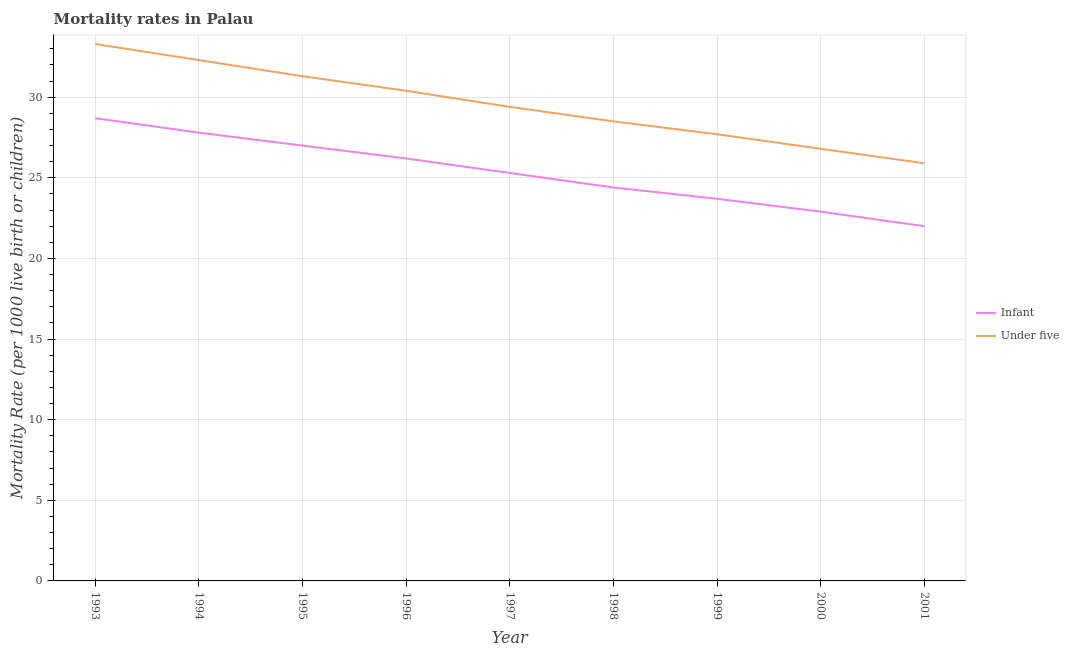What is the under-5 mortality rate in 1995?
Your answer should be compact. 31.3. Across all years, what is the maximum infant mortality rate?
Your response must be concise. 28.7. Across all years, what is the minimum under-5 mortality rate?
Your answer should be very brief. 25.9. In which year was the under-5 mortality rate minimum?
Your answer should be compact. 2001. What is the total under-5 mortality rate in the graph?
Your response must be concise. 265.6. What is the difference between the under-5 mortality rate in 1994 and that in 1995?
Ensure brevity in your answer.  1. What is the difference between the infant mortality rate in 1993 and the under-5 mortality rate in 1994?
Your response must be concise. -3.6. What is the average infant mortality rate per year?
Keep it short and to the point. 25.33. In the year 1997, what is the difference between the infant mortality rate and under-5 mortality rate?
Offer a terse response. -4.1. What is the ratio of the infant mortality rate in 1998 to that in 2000?
Make the answer very short. 1.07. Is the difference between the under-5 mortality rate in 1995 and 2001 greater than the difference between the infant mortality rate in 1995 and 2001?
Offer a terse response. Yes. What is the difference between the highest and the lowest under-5 mortality rate?
Offer a very short reply. 7.4. In how many years, is the under-5 mortality rate greater than the average under-5 mortality rate taken over all years?
Make the answer very short. 4. Is the sum of the infant mortality rate in 1997 and 2000 greater than the maximum under-5 mortality rate across all years?
Make the answer very short. Yes. Does the under-5 mortality rate monotonically increase over the years?
Ensure brevity in your answer.  No. How many years are there in the graph?
Your response must be concise. 9. Are the values on the major ticks of Y-axis written in scientific E-notation?
Your answer should be very brief. No. Does the graph contain any zero values?
Offer a terse response. No. Where does the legend appear in the graph?
Your answer should be compact. Center right. What is the title of the graph?
Ensure brevity in your answer.  Mortality rates in Palau. What is the label or title of the X-axis?
Provide a succinct answer. Year. What is the label or title of the Y-axis?
Provide a succinct answer. Mortality Rate (per 1000 live birth or children). What is the Mortality Rate (per 1000 live birth or children) of Infant in 1993?
Give a very brief answer. 28.7. What is the Mortality Rate (per 1000 live birth or children) in Under five in 1993?
Keep it short and to the point. 33.3. What is the Mortality Rate (per 1000 live birth or children) in Infant in 1994?
Your answer should be very brief. 27.8. What is the Mortality Rate (per 1000 live birth or children) in Under five in 1994?
Your answer should be very brief. 32.3. What is the Mortality Rate (per 1000 live birth or children) of Infant in 1995?
Give a very brief answer. 27. What is the Mortality Rate (per 1000 live birth or children) in Under five in 1995?
Keep it short and to the point. 31.3. What is the Mortality Rate (per 1000 live birth or children) in Infant in 1996?
Offer a very short reply. 26.2. What is the Mortality Rate (per 1000 live birth or children) of Under five in 1996?
Keep it short and to the point. 30.4. What is the Mortality Rate (per 1000 live birth or children) in Infant in 1997?
Provide a short and direct response. 25.3. What is the Mortality Rate (per 1000 live birth or children) of Under five in 1997?
Keep it short and to the point. 29.4. What is the Mortality Rate (per 1000 live birth or children) in Infant in 1998?
Offer a very short reply. 24.4. What is the Mortality Rate (per 1000 live birth or children) of Under five in 1998?
Make the answer very short. 28.5. What is the Mortality Rate (per 1000 live birth or children) of Infant in 1999?
Make the answer very short. 23.7. What is the Mortality Rate (per 1000 live birth or children) of Under five in 1999?
Your answer should be very brief. 27.7. What is the Mortality Rate (per 1000 live birth or children) in Infant in 2000?
Your response must be concise. 22.9. What is the Mortality Rate (per 1000 live birth or children) in Under five in 2000?
Provide a succinct answer. 26.8. What is the Mortality Rate (per 1000 live birth or children) of Infant in 2001?
Keep it short and to the point. 22. What is the Mortality Rate (per 1000 live birth or children) of Under five in 2001?
Provide a short and direct response. 25.9. Across all years, what is the maximum Mortality Rate (per 1000 live birth or children) of Infant?
Your answer should be very brief. 28.7. Across all years, what is the maximum Mortality Rate (per 1000 live birth or children) of Under five?
Your response must be concise. 33.3. Across all years, what is the minimum Mortality Rate (per 1000 live birth or children) of Under five?
Your response must be concise. 25.9. What is the total Mortality Rate (per 1000 live birth or children) in Infant in the graph?
Your response must be concise. 228. What is the total Mortality Rate (per 1000 live birth or children) of Under five in the graph?
Offer a terse response. 265.6. What is the difference between the Mortality Rate (per 1000 live birth or children) in Under five in 1993 and that in 1994?
Make the answer very short. 1. What is the difference between the Mortality Rate (per 1000 live birth or children) in Under five in 1993 and that in 1997?
Your response must be concise. 3.9. What is the difference between the Mortality Rate (per 1000 live birth or children) in Infant in 1993 and that in 1998?
Offer a very short reply. 4.3. What is the difference between the Mortality Rate (per 1000 live birth or children) in Infant in 1993 and that in 2000?
Provide a succinct answer. 5.8. What is the difference between the Mortality Rate (per 1000 live birth or children) of Under five in 1993 and that in 2000?
Ensure brevity in your answer.  6.5. What is the difference between the Mortality Rate (per 1000 live birth or children) in Infant in 1994 and that in 1995?
Provide a short and direct response. 0.8. What is the difference between the Mortality Rate (per 1000 live birth or children) of Infant in 1994 and that in 1996?
Your response must be concise. 1.6. What is the difference between the Mortality Rate (per 1000 live birth or children) of Under five in 1994 and that in 1996?
Give a very brief answer. 1.9. What is the difference between the Mortality Rate (per 1000 live birth or children) of Infant in 1994 and that in 1997?
Offer a terse response. 2.5. What is the difference between the Mortality Rate (per 1000 live birth or children) in Under five in 1994 and that in 1998?
Keep it short and to the point. 3.8. What is the difference between the Mortality Rate (per 1000 live birth or children) of Infant in 1994 and that in 1999?
Offer a terse response. 4.1. What is the difference between the Mortality Rate (per 1000 live birth or children) in Under five in 1994 and that in 1999?
Provide a short and direct response. 4.6. What is the difference between the Mortality Rate (per 1000 live birth or children) of Under five in 1994 and that in 2000?
Make the answer very short. 5.5. What is the difference between the Mortality Rate (per 1000 live birth or children) of Under five in 1994 and that in 2001?
Ensure brevity in your answer.  6.4. What is the difference between the Mortality Rate (per 1000 live birth or children) in Under five in 1995 and that in 1996?
Offer a very short reply. 0.9. What is the difference between the Mortality Rate (per 1000 live birth or children) of Infant in 1995 and that in 1997?
Offer a very short reply. 1.7. What is the difference between the Mortality Rate (per 1000 live birth or children) in Infant in 1995 and that in 1998?
Offer a very short reply. 2.6. What is the difference between the Mortality Rate (per 1000 live birth or children) of Under five in 1995 and that in 1998?
Offer a very short reply. 2.8. What is the difference between the Mortality Rate (per 1000 live birth or children) in Under five in 1995 and that in 1999?
Provide a succinct answer. 3.6. What is the difference between the Mortality Rate (per 1000 live birth or children) in Infant in 1995 and that in 2000?
Make the answer very short. 4.1. What is the difference between the Mortality Rate (per 1000 live birth or children) in Under five in 1995 and that in 2001?
Your answer should be compact. 5.4. What is the difference between the Mortality Rate (per 1000 live birth or children) of Under five in 1996 and that in 1997?
Give a very brief answer. 1. What is the difference between the Mortality Rate (per 1000 live birth or children) of Under five in 1996 and that in 1998?
Keep it short and to the point. 1.9. What is the difference between the Mortality Rate (per 1000 live birth or children) in Under five in 1996 and that in 1999?
Give a very brief answer. 2.7. What is the difference between the Mortality Rate (per 1000 live birth or children) of Infant in 1996 and that in 2000?
Provide a short and direct response. 3.3. What is the difference between the Mortality Rate (per 1000 live birth or children) in Infant in 1996 and that in 2001?
Offer a very short reply. 4.2. What is the difference between the Mortality Rate (per 1000 live birth or children) in Infant in 1997 and that in 1998?
Offer a very short reply. 0.9. What is the difference between the Mortality Rate (per 1000 live birth or children) of Infant in 1997 and that in 1999?
Make the answer very short. 1.6. What is the difference between the Mortality Rate (per 1000 live birth or children) in Infant in 1997 and that in 2000?
Your response must be concise. 2.4. What is the difference between the Mortality Rate (per 1000 live birth or children) of Infant in 1997 and that in 2001?
Keep it short and to the point. 3.3. What is the difference between the Mortality Rate (per 1000 live birth or children) in Under five in 1997 and that in 2001?
Offer a very short reply. 3.5. What is the difference between the Mortality Rate (per 1000 live birth or children) of Infant in 1998 and that in 2000?
Give a very brief answer. 1.5. What is the difference between the Mortality Rate (per 1000 live birth or children) of Under five in 1998 and that in 2000?
Give a very brief answer. 1.7. What is the difference between the Mortality Rate (per 1000 live birth or children) of Infant in 1998 and that in 2001?
Your answer should be very brief. 2.4. What is the difference between the Mortality Rate (per 1000 live birth or children) of Infant in 1999 and that in 2000?
Your answer should be very brief. 0.8. What is the difference between the Mortality Rate (per 1000 live birth or children) in Infant in 1999 and that in 2001?
Your answer should be compact. 1.7. What is the difference between the Mortality Rate (per 1000 live birth or children) of Under five in 1999 and that in 2001?
Offer a terse response. 1.8. What is the difference between the Mortality Rate (per 1000 live birth or children) of Under five in 2000 and that in 2001?
Your answer should be very brief. 0.9. What is the difference between the Mortality Rate (per 1000 live birth or children) of Infant in 1993 and the Mortality Rate (per 1000 live birth or children) of Under five in 1994?
Offer a terse response. -3.6. What is the difference between the Mortality Rate (per 1000 live birth or children) in Infant in 1993 and the Mortality Rate (per 1000 live birth or children) in Under five in 1995?
Provide a short and direct response. -2.6. What is the difference between the Mortality Rate (per 1000 live birth or children) in Infant in 1993 and the Mortality Rate (per 1000 live birth or children) in Under five in 1996?
Your answer should be very brief. -1.7. What is the difference between the Mortality Rate (per 1000 live birth or children) in Infant in 1993 and the Mortality Rate (per 1000 live birth or children) in Under five in 1998?
Give a very brief answer. 0.2. What is the difference between the Mortality Rate (per 1000 live birth or children) of Infant in 1993 and the Mortality Rate (per 1000 live birth or children) of Under five in 1999?
Give a very brief answer. 1. What is the difference between the Mortality Rate (per 1000 live birth or children) in Infant in 1993 and the Mortality Rate (per 1000 live birth or children) in Under five in 2000?
Your response must be concise. 1.9. What is the difference between the Mortality Rate (per 1000 live birth or children) of Infant in 1993 and the Mortality Rate (per 1000 live birth or children) of Under five in 2001?
Provide a short and direct response. 2.8. What is the difference between the Mortality Rate (per 1000 live birth or children) of Infant in 1994 and the Mortality Rate (per 1000 live birth or children) of Under five in 1996?
Make the answer very short. -2.6. What is the difference between the Mortality Rate (per 1000 live birth or children) in Infant in 1994 and the Mortality Rate (per 1000 live birth or children) in Under five in 1999?
Provide a short and direct response. 0.1. What is the difference between the Mortality Rate (per 1000 live birth or children) in Infant in 1995 and the Mortality Rate (per 1000 live birth or children) in Under five in 1996?
Your answer should be very brief. -3.4. What is the difference between the Mortality Rate (per 1000 live birth or children) of Infant in 1995 and the Mortality Rate (per 1000 live birth or children) of Under five in 1999?
Make the answer very short. -0.7. What is the difference between the Mortality Rate (per 1000 live birth or children) of Infant in 1995 and the Mortality Rate (per 1000 live birth or children) of Under five in 2000?
Offer a very short reply. 0.2. What is the difference between the Mortality Rate (per 1000 live birth or children) in Infant in 1995 and the Mortality Rate (per 1000 live birth or children) in Under five in 2001?
Make the answer very short. 1.1. What is the difference between the Mortality Rate (per 1000 live birth or children) of Infant in 1996 and the Mortality Rate (per 1000 live birth or children) of Under five in 1997?
Your response must be concise. -3.2. What is the difference between the Mortality Rate (per 1000 live birth or children) in Infant in 1996 and the Mortality Rate (per 1000 live birth or children) in Under five in 1999?
Give a very brief answer. -1.5. What is the difference between the Mortality Rate (per 1000 live birth or children) of Infant in 1996 and the Mortality Rate (per 1000 live birth or children) of Under five in 2000?
Ensure brevity in your answer.  -0.6. What is the difference between the Mortality Rate (per 1000 live birth or children) in Infant in 1996 and the Mortality Rate (per 1000 live birth or children) in Under five in 2001?
Keep it short and to the point. 0.3. What is the difference between the Mortality Rate (per 1000 live birth or children) of Infant in 1997 and the Mortality Rate (per 1000 live birth or children) of Under five in 1999?
Provide a succinct answer. -2.4. What is the difference between the Mortality Rate (per 1000 live birth or children) in Infant in 1997 and the Mortality Rate (per 1000 live birth or children) in Under five in 2000?
Make the answer very short. -1.5. What is the difference between the Mortality Rate (per 1000 live birth or children) of Infant in 1998 and the Mortality Rate (per 1000 live birth or children) of Under five in 2000?
Your response must be concise. -2.4. What is the difference between the Mortality Rate (per 1000 live birth or children) of Infant in 1999 and the Mortality Rate (per 1000 live birth or children) of Under five in 2000?
Offer a terse response. -3.1. What is the difference between the Mortality Rate (per 1000 live birth or children) in Infant in 1999 and the Mortality Rate (per 1000 live birth or children) in Under five in 2001?
Ensure brevity in your answer.  -2.2. What is the average Mortality Rate (per 1000 live birth or children) of Infant per year?
Provide a succinct answer. 25.33. What is the average Mortality Rate (per 1000 live birth or children) of Under five per year?
Your answer should be compact. 29.51. In the year 1994, what is the difference between the Mortality Rate (per 1000 live birth or children) of Infant and Mortality Rate (per 1000 live birth or children) of Under five?
Keep it short and to the point. -4.5. In the year 1995, what is the difference between the Mortality Rate (per 1000 live birth or children) of Infant and Mortality Rate (per 1000 live birth or children) of Under five?
Offer a very short reply. -4.3. In the year 1996, what is the difference between the Mortality Rate (per 1000 live birth or children) of Infant and Mortality Rate (per 1000 live birth or children) of Under five?
Give a very brief answer. -4.2. In the year 1999, what is the difference between the Mortality Rate (per 1000 live birth or children) of Infant and Mortality Rate (per 1000 live birth or children) of Under five?
Ensure brevity in your answer.  -4. What is the ratio of the Mortality Rate (per 1000 live birth or children) of Infant in 1993 to that in 1994?
Offer a terse response. 1.03. What is the ratio of the Mortality Rate (per 1000 live birth or children) in Under five in 1993 to that in 1994?
Your answer should be compact. 1.03. What is the ratio of the Mortality Rate (per 1000 live birth or children) of Infant in 1993 to that in 1995?
Offer a terse response. 1.06. What is the ratio of the Mortality Rate (per 1000 live birth or children) in Under five in 1993 to that in 1995?
Your answer should be compact. 1.06. What is the ratio of the Mortality Rate (per 1000 live birth or children) of Infant in 1993 to that in 1996?
Give a very brief answer. 1.1. What is the ratio of the Mortality Rate (per 1000 live birth or children) of Under five in 1993 to that in 1996?
Provide a succinct answer. 1.1. What is the ratio of the Mortality Rate (per 1000 live birth or children) in Infant in 1993 to that in 1997?
Ensure brevity in your answer.  1.13. What is the ratio of the Mortality Rate (per 1000 live birth or children) in Under five in 1993 to that in 1997?
Offer a very short reply. 1.13. What is the ratio of the Mortality Rate (per 1000 live birth or children) of Infant in 1993 to that in 1998?
Your answer should be compact. 1.18. What is the ratio of the Mortality Rate (per 1000 live birth or children) of Under five in 1993 to that in 1998?
Provide a short and direct response. 1.17. What is the ratio of the Mortality Rate (per 1000 live birth or children) in Infant in 1993 to that in 1999?
Provide a short and direct response. 1.21. What is the ratio of the Mortality Rate (per 1000 live birth or children) in Under five in 1993 to that in 1999?
Your answer should be compact. 1.2. What is the ratio of the Mortality Rate (per 1000 live birth or children) of Infant in 1993 to that in 2000?
Provide a succinct answer. 1.25. What is the ratio of the Mortality Rate (per 1000 live birth or children) of Under five in 1993 to that in 2000?
Your answer should be compact. 1.24. What is the ratio of the Mortality Rate (per 1000 live birth or children) of Infant in 1993 to that in 2001?
Provide a short and direct response. 1.3. What is the ratio of the Mortality Rate (per 1000 live birth or children) in Under five in 1993 to that in 2001?
Your answer should be compact. 1.29. What is the ratio of the Mortality Rate (per 1000 live birth or children) of Infant in 1994 to that in 1995?
Offer a terse response. 1.03. What is the ratio of the Mortality Rate (per 1000 live birth or children) of Under five in 1994 to that in 1995?
Offer a very short reply. 1.03. What is the ratio of the Mortality Rate (per 1000 live birth or children) in Infant in 1994 to that in 1996?
Provide a succinct answer. 1.06. What is the ratio of the Mortality Rate (per 1000 live birth or children) in Under five in 1994 to that in 1996?
Your answer should be compact. 1.06. What is the ratio of the Mortality Rate (per 1000 live birth or children) of Infant in 1994 to that in 1997?
Offer a very short reply. 1.1. What is the ratio of the Mortality Rate (per 1000 live birth or children) in Under five in 1994 to that in 1997?
Provide a short and direct response. 1.1. What is the ratio of the Mortality Rate (per 1000 live birth or children) in Infant in 1994 to that in 1998?
Give a very brief answer. 1.14. What is the ratio of the Mortality Rate (per 1000 live birth or children) of Under five in 1994 to that in 1998?
Your answer should be very brief. 1.13. What is the ratio of the Mortality Rate (per 1000 live birth or children) of Infant in 1994 to that in 1999?
Make the answer very short. 1.17. What is the ratio of the Mortality Rate (per 1000 live birth or children) of Under five in 1994 to that in 1999?
Provide a succinct answer. 1.17. What is the ratio of the Mortality Rate (per 1000 live birth or children) in Infant in 1994 to that in 2000?
Your answer should be compact. 1.21. What is the ratio of the Mortality Rate (per 1000 live birth or children) in Under five in 1994 to that in 2000?
Give a very brief answer. 1.21. What is the ratio of the Mortality Rate (per 1000 live birth or children) in Infant in 1994 to that in 2001?
Your answer should be very brief. 1.26. What is the ratio of the Mortality Rate (per 1000 live birth or children) in Under five in 1994 to that in 2001?
Keep it short and to the point. 1.25. What is the ratio of the Mortality Rate (per 1000 live birth or children) in Infant in 1995 to that in 1996?
Provide a succinct answer. 1.03. What is the ratio of the Mortality Rate (per 1000 live birth or children) of Under five in 1995 to that in 1996?
Ensure brevity in your answer.  1.03. What is the ratio of the Mortality Rate (per 1000 live birth or children) in Infant in 1995 to that in 1997?
Make the answer very short. 1.07. What is the ratio of the Mortality Rate (per 1000 live birth or children) of Under five in 1995 to that in 1997?
Your answer should be very brief. 1.06. What is the ratio of the Mortality Rate (per 1000 live birth or children) in Infant in 1995 to that in 1998?
Ensure brevity in your answer.  1.11. What is the ratio of the Mortality Rate (per 1000 live birth or children) in Under five in 1995 to that in 1998?
Ensure brevity in your answer.  1.1. What is the ratio of the Mortality Rate (per 1000 live birth or children) of Infant in 1995 to that in 1999?
Provide a succinct answer. 1.14. What is the ratio of the Mortality Rate (per 1000 live birth or children) of Under five in 1995 to that in 1999?
Provide a succinct answer. 1.13. What is the ratio of the Mortality Rate (per 1000 live birth or children) of Infant in 1995 to that in 2000?
Ensure brevity in your answer.  1.18. What is the ratio of the Mortality Rate (per 1000 live birth or children) in Under five in 1995 to that in 2000?
Your answer should be very brief. 1.17. What is the ratio of the Mortality Rate (per 1000 live birth or children) of Infant in 1995 to that in 2001?
Offer a terse response. 1.23. What is the ratio of the Mortality Rate (per 1000 live birth or children) of Under five in 1995 to that in 2001?
Offer a terse response. 1.21. What is the ratio of the Mortality Rate (per 1000 live birth or children) in Infant in 1996 to that in 1997?
Offer a terse response. 1.04. What is the ratio of the Mortality Rate (per 1000 live birth or children) of Under five in 1996 to that in 1997?
Ensure brevity in your answer.  1.03. What is the ratio of the Mortality Rate (per 1000 live birth or children) in Infant in 1996 to that in 1998?
Your answer should be compact. 1.07. What is the ratio of the Mortality Rate (per 1000 live birth or children) of Under five in 1996 to that in 1998?
Provide a short and direct response. 1.07. What is the ratio of the Mortality Rate (per 1000 live birth or children) of Infant in 1996 to that in 1999?
Make the answer very short. 1.11. What is the ratio of the Mortality Rate (per 1000 live birth or children) in Under five in 1996 to that in 1999?
Provide a short and direct response. 1.1. What is the ratio of the Mortality Rate (per 1000 live birth or children) in Infant in 1996 to that in 2000?
Your answer should be very brief. 1.14. What is the ratio of the Mortality Rate (per 1000 live birth or children) in Under five in 1996 to that in 2000?
Offer a terse response. 1.13. What is the ratio of the Mortality Rate (per 1000 live birth or children) of Infant in 1996 to that in 2001?
Offer a very short reply. 1.19. What is the ratio of the Mortality Rate (per 1000 live birth or children) in Under five in 1996 to that in 2001?
Make the answer very short. 1.17. What is the ratio of the Mortality Rate (per 1000 live birth or children) in Infant in 1997 to that in 1998?
Your answer should be very brief. 1.04. What is the ratio of the Mortality Rate (per 1000 live birth or children) of Under five in 1997 to that in 1998?
Offer a terse response. 1.03. What is the ratio of the Mortality Rate (per 1000 live birth or children) of Infant in 1997 to that in 1999?
Offer a very short reply. 1.07. What is the ratio of the Mortality Rate (per 1000 live birth or children) in Under five in 1997 to that in 1999?
Keep it short and to the point. 1.06. What is the ratio of the Mortality Rate (per 1000 live birth or children) in Infant in 1997 to that in 2000?
Give a very brief answer. 1.1. What is the ratio of the Mortality Rate (per 1000 live birth or children) of Under five in 1997 to that in 2000?
Ensure brevity in your answer.  1.1. What is the ratio of the Mortality Rate (per 1000 live birth or children) of Infant in 1997 to that in 2001?
Your answer should be very brief. 1.15. What is the ratio of the Mortality Rate (per 1000 live birth or children) of Under five in 1997 to that in 2001?
Offer a terse response. 1.14. What is the ratio of the Mortality Rate (per 1000 live birth or children) of Infant in 1998 to that in 1999?
Offer a very short reply. 1.03. What is the ratio of the Mortality Rate (per 1000 live birth or children) in Under five in 1998 to that in 1999?
Provide a succinct answer. 1.03. What is the ratio of the Mortality Rate (per 1000 live birth or children) of Infant in 1998 to that in 2000?
Offer a terse response. 1.07. What is the ratio of the Mortality Rate (per 1000 live birth or children) in Under five in 1998 to that in 2000?
Offer a terse response. 1.06. What is the ratio of the Mortality Rate (per 1000 live birth or children) in Infant in 1998 to that in 2001?
Offer a terse response. 1.11. What is the ratio of the Mortality Rate (per 1000 live birth or children) of Under five in 1998 to that in 2001?
Offer a very short reply. 1.1. What is the ratio of the Mortality Rate (per 1000 live birth or children) in Infant in 1999 to that in 2000?
Give a very brief answer. 1.03. What is the ratio of the Mortality Rate (per 1000 live birth or children) in Under five in 1999 to that in 2000?
Your answer should be compact. 1.03. What is the ratio of the Mortality Rate (per 1000 live birth or children) of Infant in 1999 to that in 2001?
Your response must be concise. 1.08. What is the ratio of the Mortality Rate (per 1000 live birth or children) of Under five in 1999 to that in 2001?
Your answer should be very brief. 1.07. What is the ratio of the Mortality Rate (per 1000 live birth or children) in Infant in 2000 to that in 2001?
Give a very brief answer. 1.04. What is the ratio of the Mortality Rate (per 1000 live birth or children) of Under five in 2000 to that in 2001?
Ensure brevity in your answer.  1.03. What is the difference between the highest and the lowest Mortality Rate (per 1000 live birth or children) of Infant?
Your answer should be compact. 6.7. What is the difference between the highest and the lowest Mortality Rate (per 1000 live birth or children) in Under five?
Make the answer very short. 7.4. 